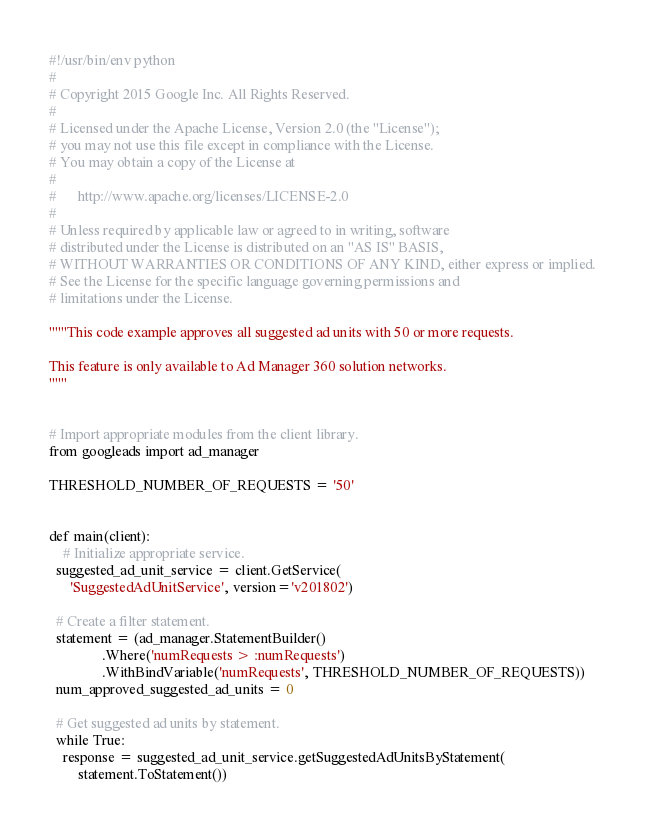<code> <loc_0><loc_0><loc_500><loc_500><_Python_>#!/usr/bin/env python
#
# Copyright 2015 Google Inc. All Rights Reserved.
#
# Licensed under the Apache License, Version 2.0 (the "License");
# you may not use this file except in compliance with the License.
# You may obtain a copy of the License at
#
#      http://www.apache.org/licenses/LICENSE-2.0
#
# Unless required by applicable law or agreed to in writing, software
# distributed under the License is distributed on an "AS IS" BASIS,
# WITHOUT WARRANTIES OR CONDITIONS OF ANY KIND, either express or implied.
# See the License for the specific language governing permissions and
# limitations under the License.

"""This code example approves all suggested ad units with 50 or more requests.

This feature is only available to Ad Manager 360 solution networks.
"""


# Import appropriate modules from the client library.
from googleads import ad_manager

THRESHOLD_NUMBER_OF_REQUESTS = '50'


def main(client):
    # Initialize appropriate service.
  suggested_ad_unit_service = client.GetService(
      'SuggestedAdUnitService', version='v201802')

  # Create a filter statement.
  statement = (ad_manager.StatementBuilder()
               .Where('numRequests > :numRequests')
               .WithBindVariable('numRequests', THRESHOLD_NUMBER_OF_REQUESTS))
  num_approved_suggested_ad_units = 0

  # Get suggested ad units by statement.
  while True:
    response = suggested_ad_unit_service.getSuggestedAdUnitsByStatement(
        statement.ToStatement())</code> 